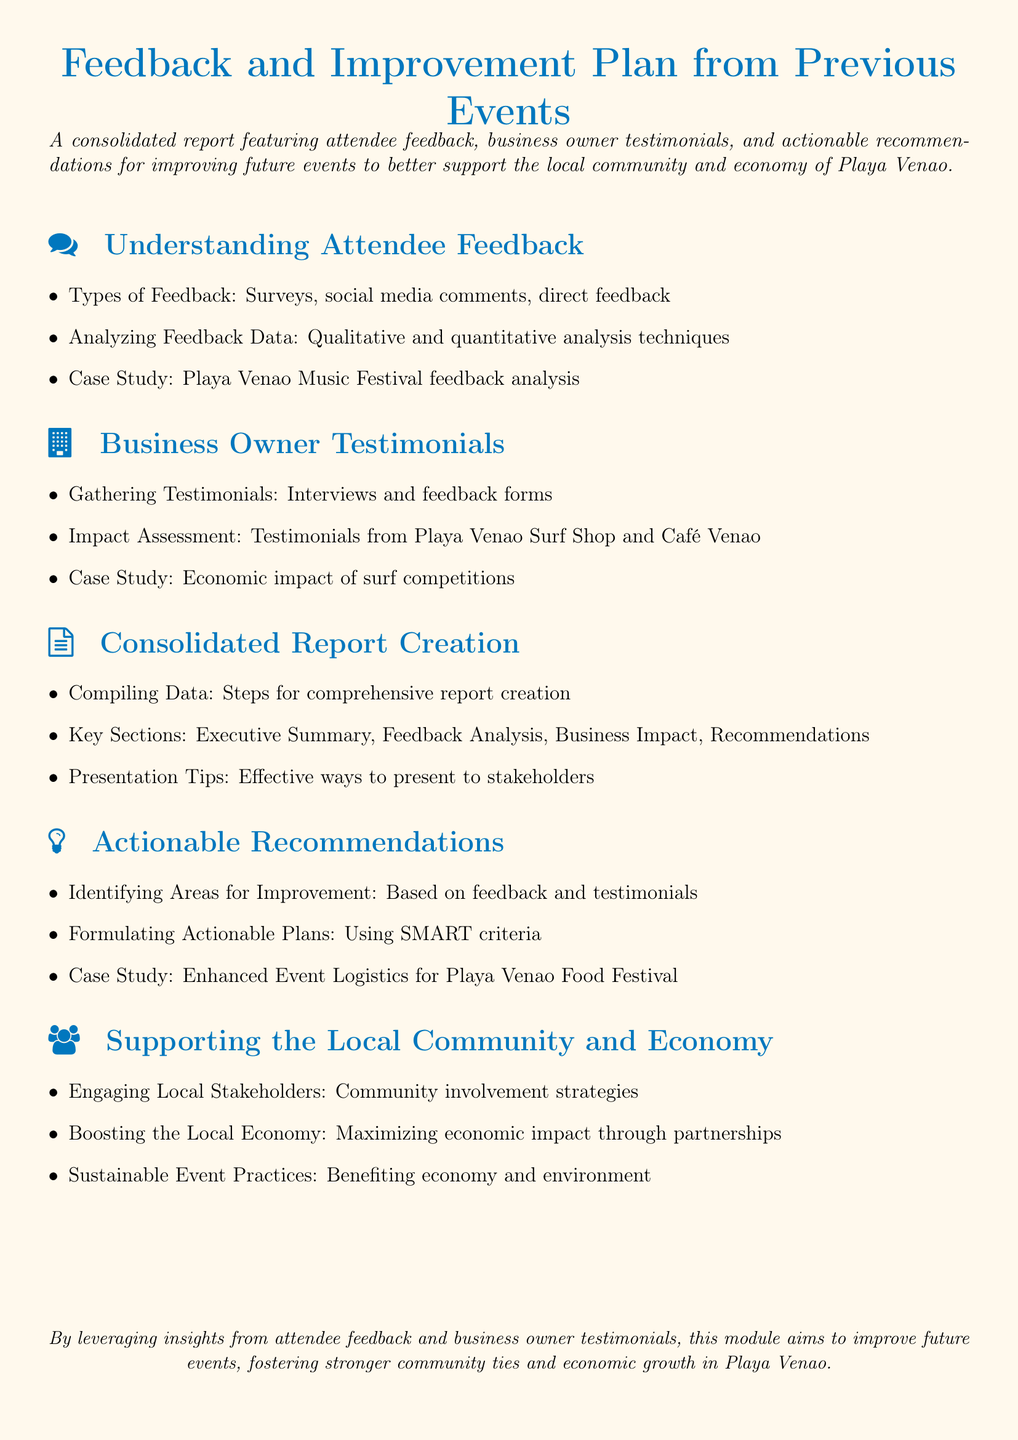what is the title of the document? The title is prominently displayed at the top of the document and summarizes its content.
Answer: Feedback and Improvement Plan from Previous Events what type of analysis techniques are used for feedback? This information is located under the section discussing attendee feedback, which mentions the methods of analysis.
Answer: Qualitative and quantitative analysis techniques which business owner's testimonial is mentioned in the document? The document lists specific businesses whose testimonials are gathered, under the related section.
Answer: Playa Venao Surf Shop and Café Venao what is one key section of the consolidated report? Key sections are outlined under the report creation portion, which indicates what should be included in the report.
Answer: Executive Summary what criteria is suggested for formulating actionable plans? The document specifies an approach for developing plans, indicating particular criteria to be used.
Answer: SMART criteria how are local stakeholders engaged according to the document? The document provides strategies for community involvement and support, as noted in its relevant section.
Answer: Community involvement strategies what case study is mentioned for improved event logistics? The document includes case studies to illustrate its points, specifically concerning event management practices.
Answer: Enhanced Event Logistics for Playa Venao Food Festival how does the document suggest boosting the local economy? This is found in the section discussing the economic impact and partnerships, which highlights strategies for economic enhancement.
Answer: Maximizing economic impact through partnerships 